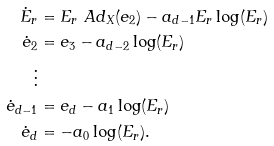<formula> <loc_0><loc_0><loc_500><loc_500>\dot { E } _ { r } & = E _ { r } \ A d _ { X } ( e _ { 2 } ) - a _ { d - 1 } E _ { r } \log ( E _ { r } ) \\ \dot { e } _ { 2 } & = e _ { 3 } - a _ { d - 2 } \log ( E _ { r } ) \\ \vdots \\ \dot { e } _ { d - 1 } & = e _ { d } - a _ { 1 } \log ( E _ { r } ) \\ \dot { e } _ { d } & = - a _ { 0 } \log ( E _ { r } ) .</formula> 